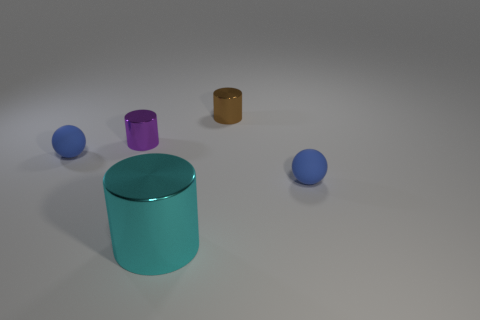Is there anything else that is the same size as the cyan cylinder?
Provide a short and direct response. No. What number of blue things are either matte objects or metallic objects?
Offer a terse response. 2. There is a cyan object that is made of the same material as the brown cylinder; what size is it?
Your response must be concise. Large. Is the tiny blue object that is on the left side of the tiny brown cylinder made of the same material as the ball that is to the right of the cyan metal object?
Give a very brief answer. Yes. What number of blocks are either large metal objects or small purple objects?
Your response must be concise. 0. There is a tiny blue matte thing on the right side of the rubber object that is on the left side of the tiny purple object; how many cyan shiny cylinders are on the left side of it?
Give a very brief answer. 1. The metallic cylinder that is on the left side of the large cyan object is what color?
Offer a terse response. Purple. Are the tiny purple cylinder and the blue thing left of the tiny brown object made of the same material?
Provide a succinct answer. No. What is the shape of the small object that is made of the same material as the purple cylinder?
Keep it short and to the point. Cylinder. How many other things are the same shape as the brown shiny thing?
Your response must be concise. 2. 